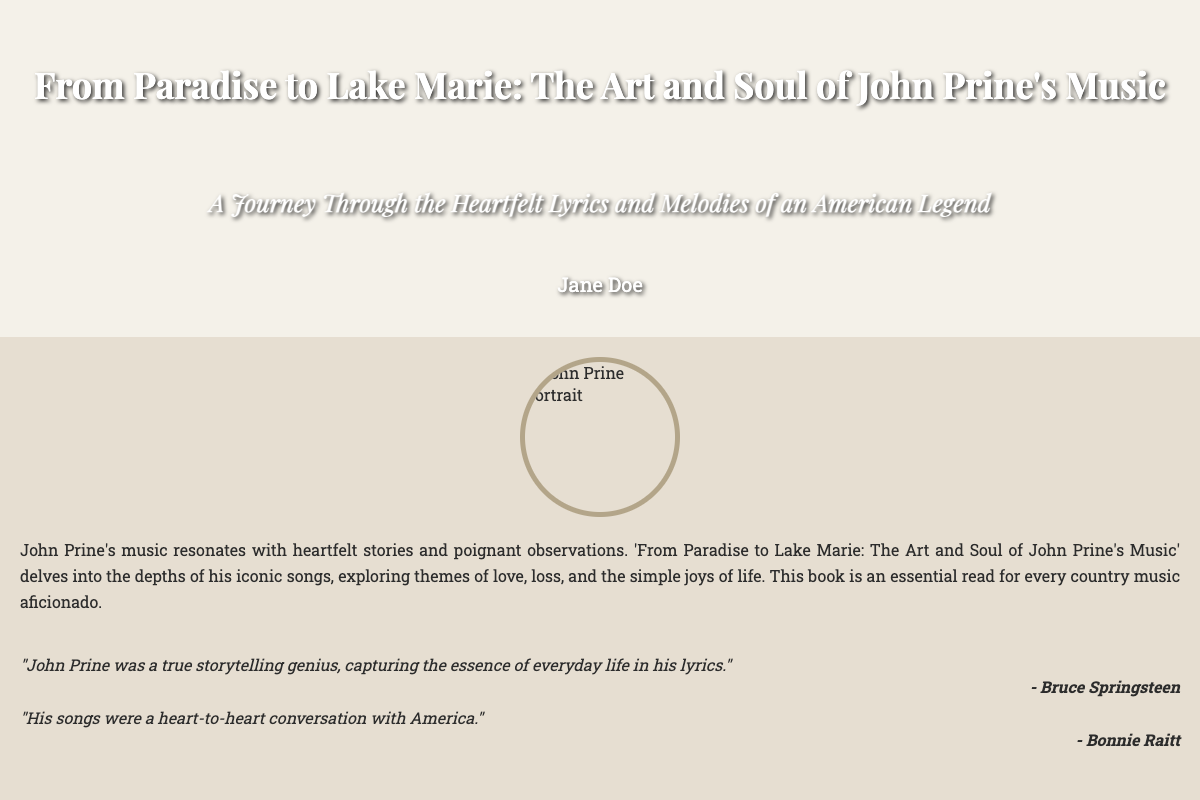What is the title of the book? The title is prominently displayed at the top of the front cover.
Answer: From Paradise to Lake Marie: The Art and Soul of John Prine's Music Who is the author of the book? The author's name is located at the bottom of the front cover.
Answer: Jane Doe What is a key theme explored in John Prine's music according to the synopsis? The synopsis mentions themes that are central to the music described in the book.
Answer: Love, loss, and the simple joys of life What design element is featured prominently on the front cover? The front cover has a background that encapsulates the essence of John Prine's music.
Answer: A guitar Which famous musician described John Prine as a storytelling genius? The back cover features quotes from notable musicians about John Prine.
Answer: Bruce Springsteen What type of book is this? The structural elements suggest the nature of the content presented in the document.
Answer: Non-fiction How many quotes are included in the back cover? The number of quotes can be counted within the quotes section of the back cover.
Answer: Two 